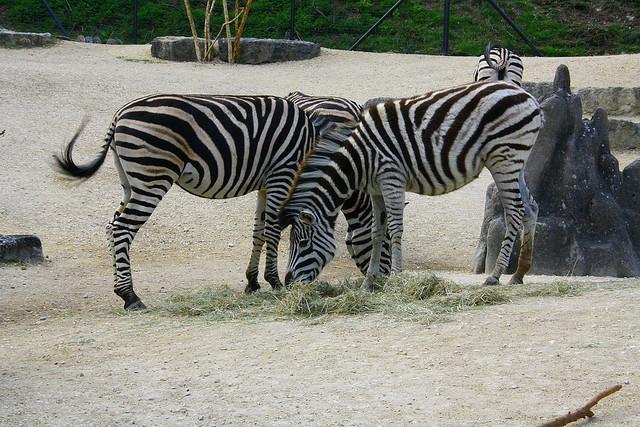What is fully visible on the animal on the left?
Select the accurate answer and provide explanation: 'Answer: answer
Rationale: rationale.'
Options: Horn, wing, tusk, tail. Answer: tail.
Rationale: This is hanging from the rear of the animal. 